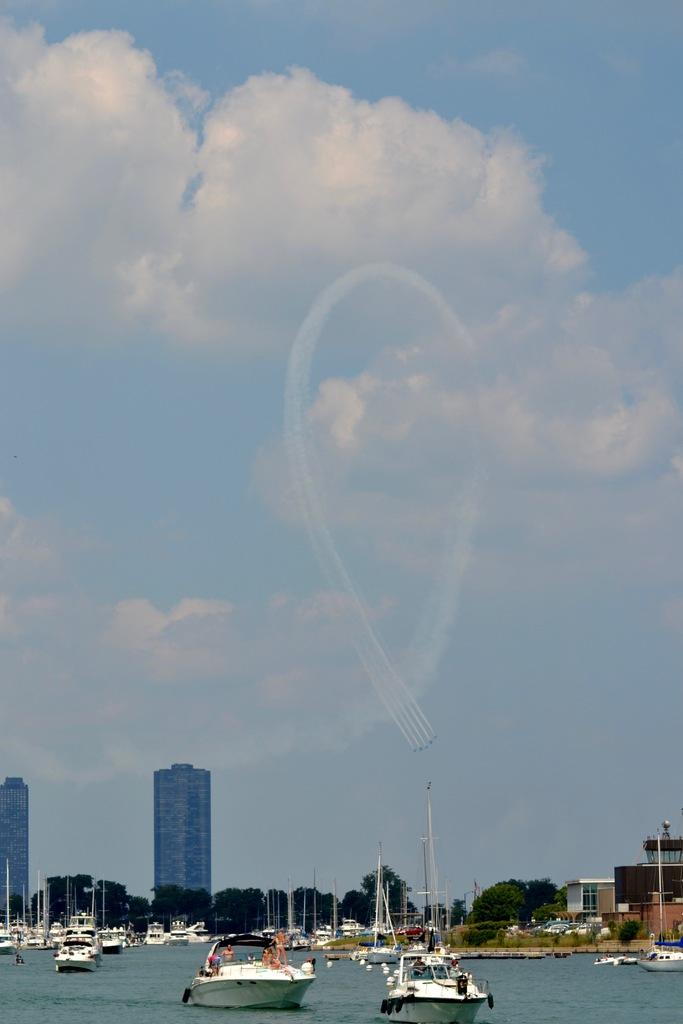What can be seen in the water in the image? There are fleets of boats in the water. What type of vegetation is visible in the image? Trees are visible in the image. What type of structures are present in the image? Buildings and towers are present in the image. What is visible in the background of the image? The sky is visible in the background. When was the image taken? The image was taken during the day. Can you tell me how many fish are swimming in the water near the boats? There is no fish visible in the image; it only shows fleets of boats in the water. What type of prison can be seen in the image? There is no prison present in the image; it features boats, trees, buildings, towers, and the sky. 